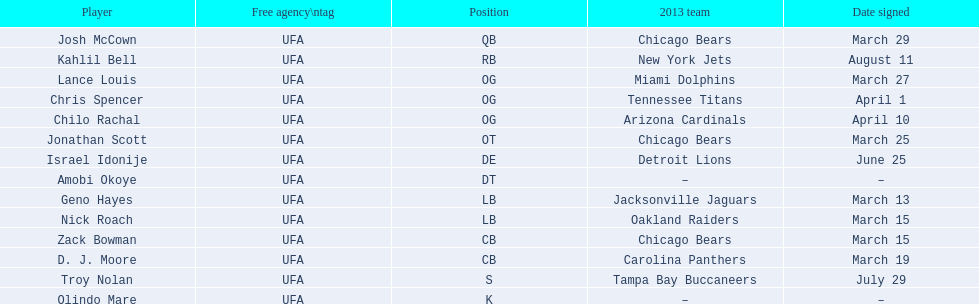Last name is also a first name beginning with "n" Troy Nolan. 